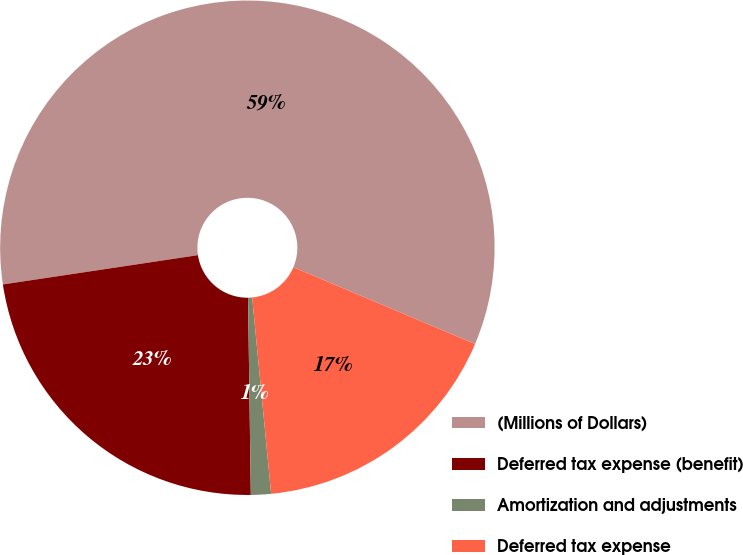Convert chart to OTSL. <chart><loc_0><loc_0><loc_500><loc_500><pie_chart><fcel>(Millions of Dollars)<fcel>Deferred tax expense (benefit)<fcel>Amortization and adjustments<fcel>Deferred tax expense<nl><fcel>58.74%<fcel>22.85%<fcel>1.31%<fcel>17.1%<nl></chart> 